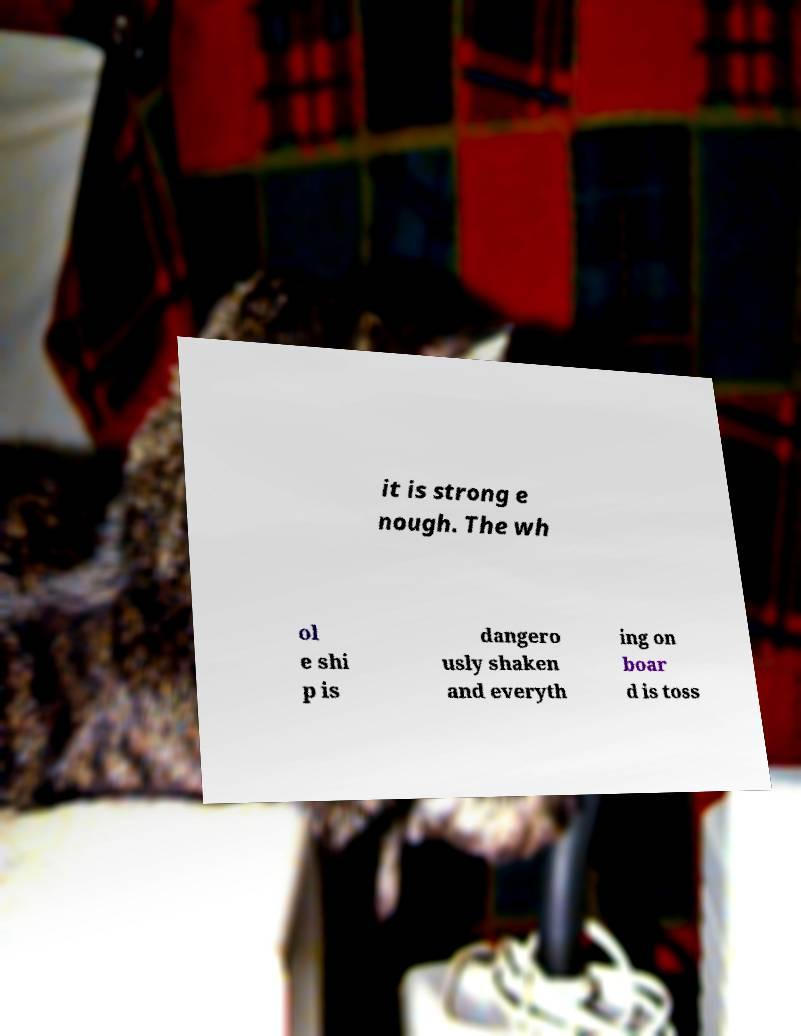Please identify and transcribe the text found in this image. it is strong e nough. The wh ol e shi p is dangero usly shaken and everyth ing on boar d is toss 